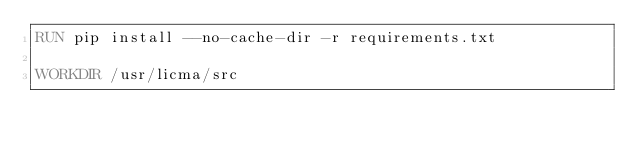Convert code to text. <code><loc_0><loc_0><loc_500><loc_500><_Dockerfile_>RUN pip install --no-cache-dir -r requirements.txt

WORKDIR /usr/licma/src</code> 